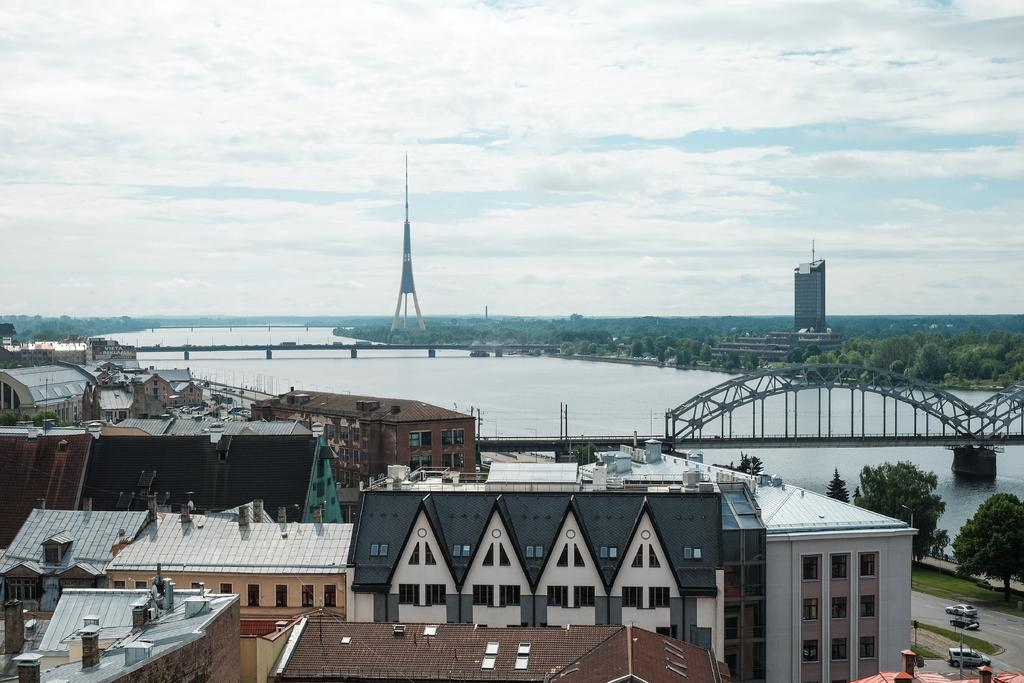What type of structures can be seen in the image? There are buildings in the image. What type of transportation infrastructure is present in the image? There is a bridge in the image. What type of vehicles can be seen on the road in the image? Vehicles are present on the road in the image. What type of natural feature is visible in the image? There is water visible in the image. What type of vegetation can be seen in the background of the image? Trees are present in the background of the image. What type of tall structure can be seen in the background of the image? There is a tower in the background of the image. What type of sky is visible in the background of the image? The sky is visible in the background of the image. How many jellyfish can be seen swimming in the water in the image? There are no jellyfish present in the image; it features buildings, a bridge, vehicles, water, trees, a tower, and the sky. What type of achievement is the person holding the key in the image? There is no person holding a key in the image; it features buildings, a bridge, vehicles, water, trees, a tower, and the sky. 